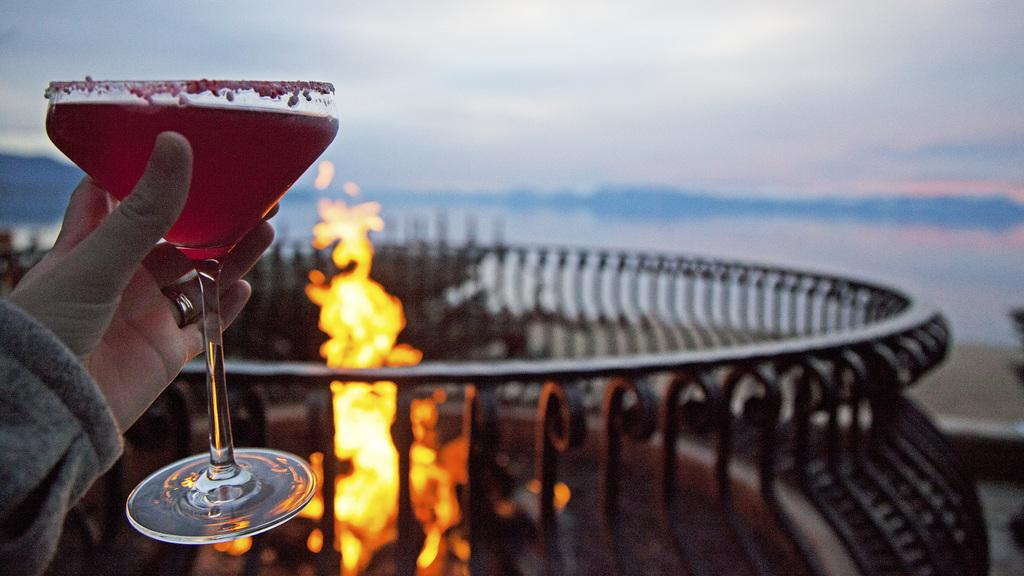What is the person in the image holding? The person is holding a glass with a drink in the image. What can be seen in the background of the image? There is fire in the background of the image. How is the fire contained in the background? There is a fence around the fire in the background. How many sheep are visible in the image? There are no sheep present in the image. What type of net is used to catch the chair in the image? There is no net or chair present in the image. 